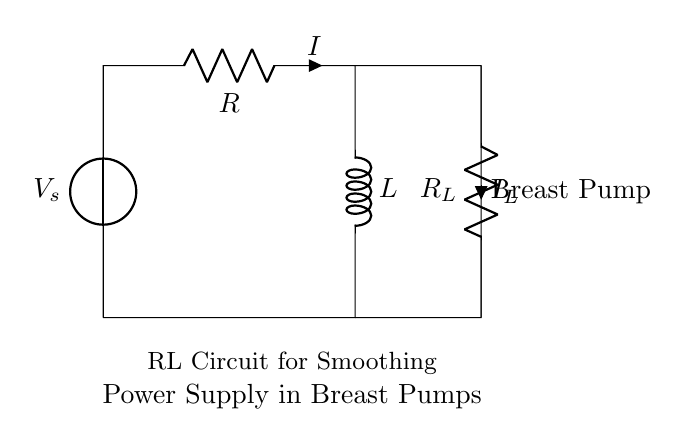What type of circuit is shown? The circuit is an RL circuit, which consists of a resistor and an inductor. It is specifically designed for smoothing the power supply.
Answer: RL circuit What is the current flowing through the resistor? The current flowing through the resistor is labeled as I in the diagram. It indicates the amount of current supplied to the circuit components.
Answer: I What component is used for smoothing the power supply? The component used for smoothing the power supply is the inductor, which helps in reducing fluctuations in voltage.
Answer: Inductor Where is the breast pump located in the circuit? The breast pump is located at the right side of the inductor connection, clearly labeled in the diagram.
Answer: Right side What does R subscript L represent? R subscript L represents an additional resistor in the circuit that may be used for load balancing or power dissipation in relation to the breast pump.
Answer: Additional resistor How does an inductor affect the current in this circuit? The inductor resists changes in current, which means it allows the current to rise or fall gradually rather than abruptly, smoothing the output.
Answer: Gradually What is the role of the voltage source in this circuit? The voltage source provides the necessary electrical energy to power the entire circuit and drive the current through the resistor and inductor.
Answer: Electrical energy 